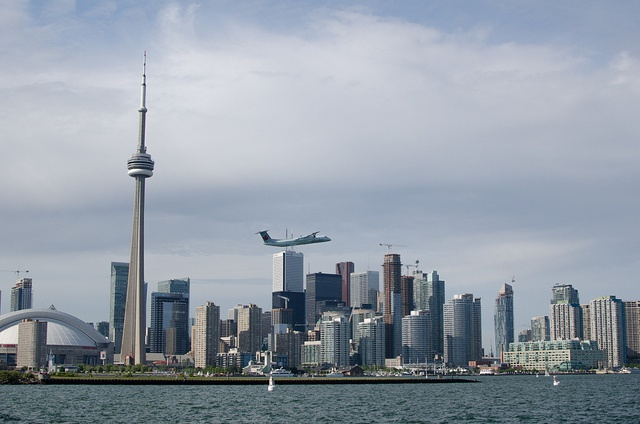Describe the objects in this image and their specific colors. I can see airplane in darkgray, blue, and gray tones, boat in darkgray, black, lightgray, and gray tones, boat in darkgray and gray tones, boat in darkgray, gray, teal, and black tones, and boat in darkgray, tan, beige, and gray tones in this image. 